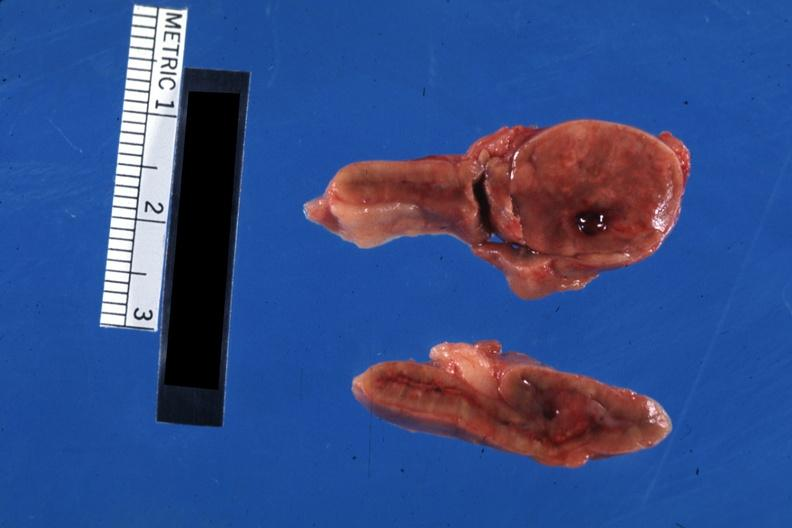where does this belong to?
Answer the question using a single word or phrase. Endocrine system 